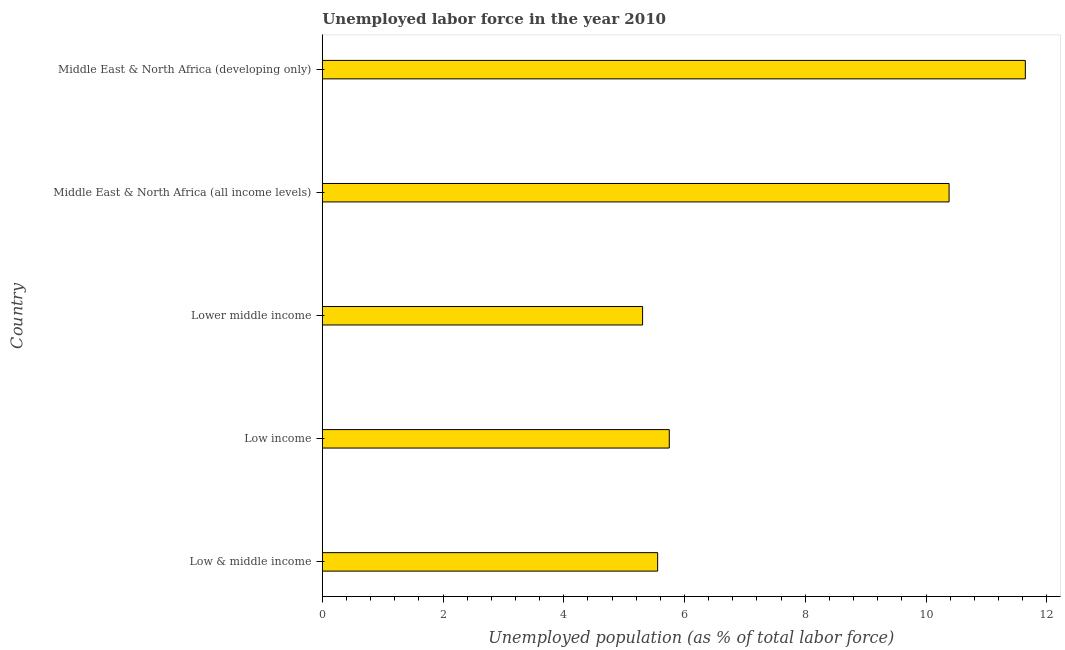Does the graph contain any zero values?
Your answer should be compact. No. Does the graph contain grids?
Provide a short and direct response. No. What is the title of the graph?
Provide a short and direct response. Unemployed labor force in the year 2010. What is the label or title of the X-axis?
Ensure brevity in your answer.  Unemployed population (as % of total labor force). What is the label or title of the Y-axis?
Your response must be concise. Country. What is the total unemployed population in Low & middle income?
Your answer should be very brief. 5.55. Across all countries, what is the maximum total unemployed population?
Your answer should be compact. 11.65. Across all countries, what is the minimum total unemployed population?
Provide a short and direct response. 5.31. In which country was the total unemployed population maximum?
Make the answer very short. Middle East & North Africa (developing only). In which country was the total unemployed population minimum?
Your answer should be compact. Lower middle income. What is the sum of the total unemployed population?
Provide a short and direct response. 38.63. What is the difference between the total unemployed population in Low income and Middle East & North Africa (developing only)?
Your response must be concise. -5.9. What is the average total unemployed population per country?
Give a very brief answer. 7.73. What is the median total unemployed population?
Ensure brevity in your answer.  5.75. In how many countries, is the total unemployed population greater than 4.4 %?
Offer a very short reply. 5. What is the ratio of the total unemployed population in Low income to that in Lower middle income?
Provide a succinct answer. 1.08. Is the total unemployed population in Low & middle income less than that in Middle East & North Africa (developing only)?
Keep it short and to the point. Yes. What is the difference between the highest and the second highest total unemployed population?
Provide a succinct answer. 1.26. Is the sum of the total unemployed population in Low & middle income and Middle East & North Africa (developing only) greater than the maximum total unemployed population across all countries?
Your response must be concise. Yes. What is the difference between the highest and the lowest total unemployed population?
Make the answer very short. 6.34. In how many countries, is the total unemployed population greater than the average total unemployed population taken over all countries?
Your response must be concise. 2. Are all the bars in the graph horizontal?
Give a very brief answer. Yes. How many countries are there in the graph?
Make the answer very short. 5. What is the difference between two consecutive major ticks on the X-axis?
Offer a terse response. 2. What is the Unemployed population (as % of total labor force) of Low & middle income?
Your response must be concise. 5.55. What is the Unemployed population (as % of total labor force) of Low income?
Give a very brief answer. 5.75. What is the Unemployed population (as % of total labor force) in Lower middle income?
Your answer should be very brief. 5.31. What is the Unemployed population (as % of total labor force) in Middle East & North Africa (all income levels)?
Give a very brief answer. 10.38. What is the Unemployed population (as % of total labor force) in Middle East & North Africa (developing only)?
Provide a short and direct response. 11.65. What is the difference between the Unemployed population (as % of total labor force) in Low & middle income and Low income?
Your answer should be compact. -0.19. What is the difference between the Unemployed population (as % of total labor force) in Low & middle income and Lower middle income?
Provide a succinct answer. 0.25. What is the difference between the Unemployed population (as % of total labor force) in Low & middle income and Middle East & North Africa (all income levels)?
Ensure brevity in your answer.  -4.83. What is the difference between the Unemployed population (as % of total labor force) in Low & middle income and Middle East & North Africa (developing only)?
Provide a short and direct response. -6.09. What is the difference between the Unemployed population (as % of total labor force) in Low income and Lower middle income?
Ensure brevity in your answer.  0.44. What is the difference between the Unemployed population (as % of total labor force) in Low income and Middle East & North Africa (all income levels)?
Offer a terse response. -4.63. What is the difference between the Unemployed population (as % of total labor force) in Low income and Middle East & North Africa (developing only)?
Provide a short and direct response. -5.9. What is the difference between the Unemployed population (as % of total labor force) in Lower middle income and Middle East & North Africa (all income levels)?
Offer a very short reply. -5.08. What is the difference between the Unemployed population (as % of total labor force) in Lower middle income and Middle East & North Africa (developing only)?
Your response must be concise. -6.34. What is the difference between the Unemployed population (as % of total labor force) in Middle East & North Africa (all income levels) and Middle East & North Africa (developing only)?
Keep it short and to the point. -1.26. What is the ratio of the Unemployed population (as % of total labor force) in Low & middle income to that in Low income?
Offer a terse response. 0.97. What is the ratio of the Unemployed population (as % of total labor force) in Low & middle income to that in Lower middle income?
Your answer should be very brief. 1.05. What is the ratio of the Unemployed population (as % of total labor force) in Low & middle income to that in Middle East & North Africa (all income levels)?
Your response must be concise. 0.54. What is the ratio of the Unemployed population (as % of total labor force) in Low & middle income to that in Middle East & North Africa (developing only)?
Make the answer very short. 0.48. What is the ratio of the Unemployed population (as % of total labor force) in Low income to that in Lower middle income?
Give a very brief answer. 1.08. What is the ratio of the Unemployed population (as % of total labor force) in Low income to that in Middle East & North Africa (all income levels)?
Offer a very short reply. 0.55. What is the ratio of the Unemployed population (as % of total labor force) in Low income to that in Middle East & North Africa (developing only)?
Provide a succinct answer. 0.49. What is the ratio of the Unemployed population (as % of total labor force) in Lower middle income to that in Middle East & North Africa (all income levels)?
Provide a succinct answer. 0.51. What is the ratio of the Unemployed population (as % of total labor force) in Lower middle income to that in Middle East & North Africa (developing only)?
Make the answer very short. 0.46. What is the ratio of the Unemployed population (as % of total labor force) in Middle East & North Africa (all income levels) to that in Middle East & North Africa (developing only)?
Provide a succinct answer. 0.89. 